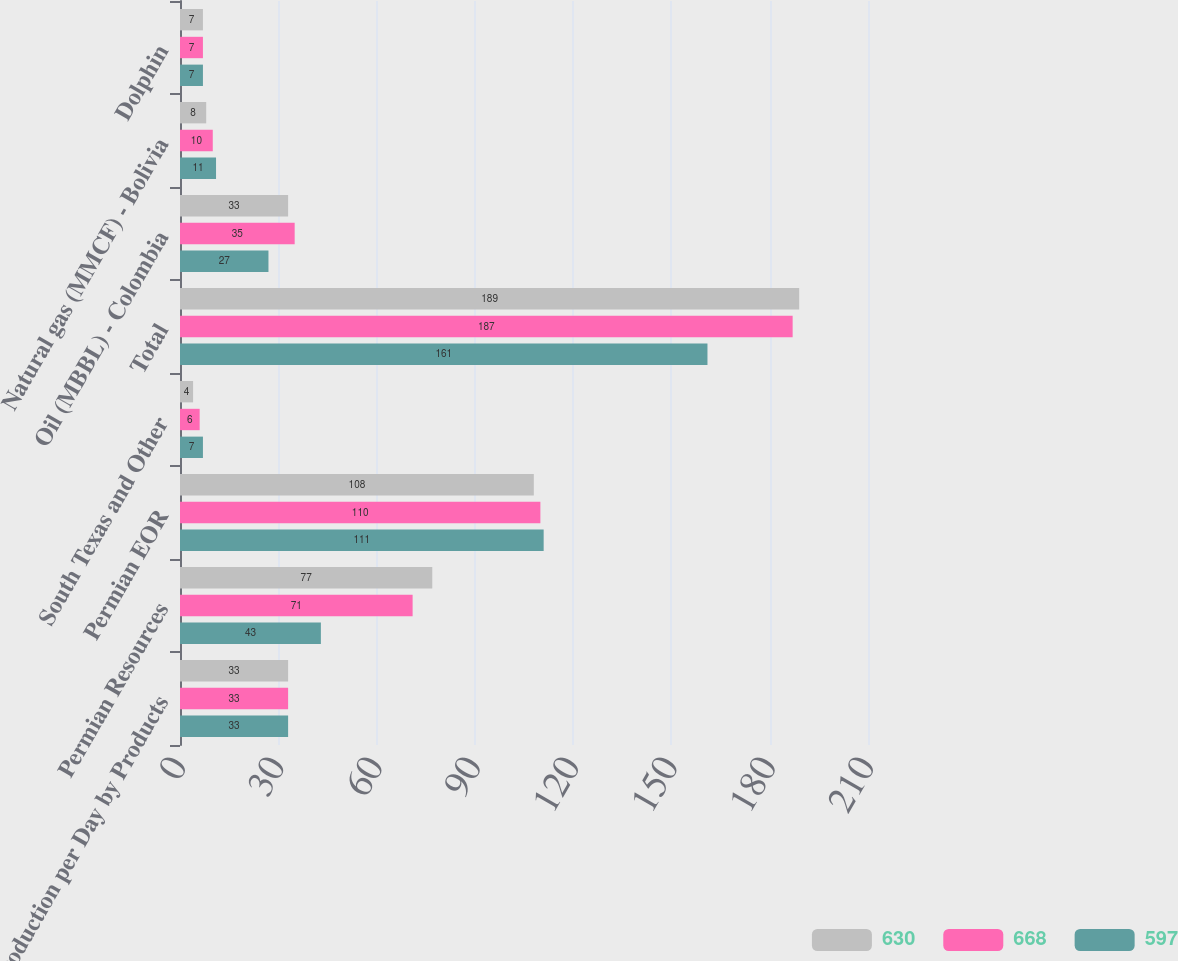Convert chart. <chart><loc_0><loc_0><loc_500><loc_500><stacked_bar_chart><ecel><fcel>Production per Day by Products<fcel>Permian Resources<fcel>Permian EOR<fcel>South Texas and Other<fcel>Total<fcel>Oil (MBBL) - Colombia<fcel>Natural gas (MMCF) - Bolivia<fcel>Dolphin<nl><fcel>630<fcel>33<fcel>77<fcel>108<fcel>4<fcel>189<fcel>33<fcel>8<fcel>7<nl><fcel>668<fcel>33<fcel>71<fcel>110<fcel>6<fcel>187<fcel>35<fcel>10<fcel>7<nl><fcel>597<fcel>33<fcel>43<fcel>111<fcel>7<fcel>161<fcel>27<fcel>11<fcel>7<nl></chart> 